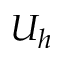Convert formula to latex. <formula><loc_0><loc_0><loc_500><loc_500>U _ { h }</formula> 